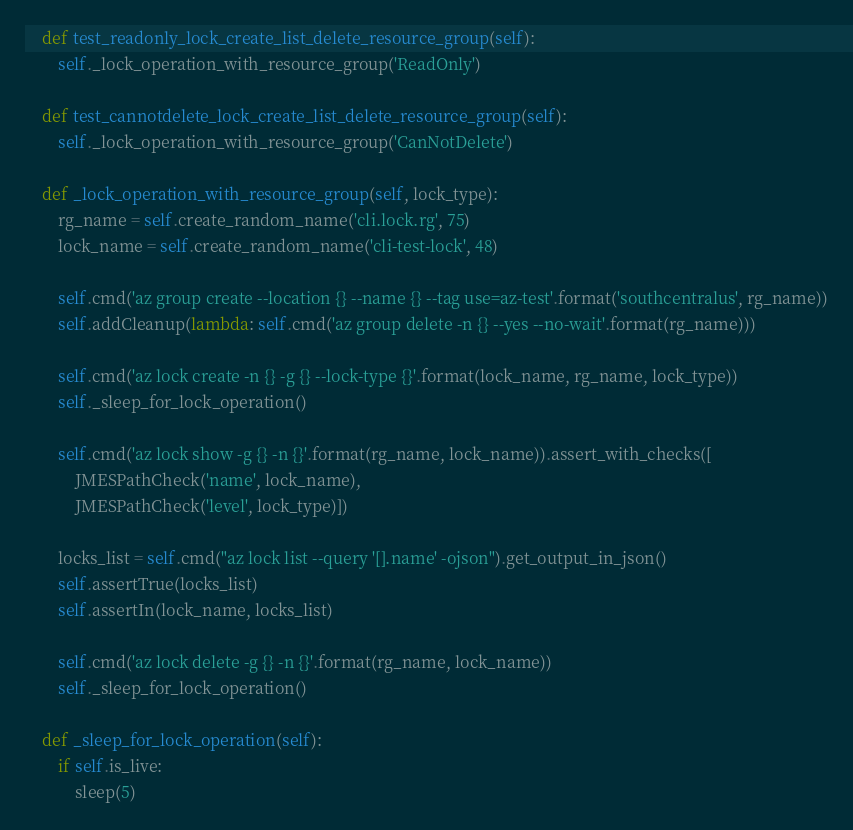Convert code to text. <code><loc_0><loc_0><loc_500><loc_500><_Python_>
    def test_readonly_lock_create_list_delete_resource_group(self):
        self._lock_operation_with_resource_group('ReadOnly')

    def test_cannotdelete_lock_create_list_delete_resource_group(self):
        self._lock_operation_with_resource_group('CanNotDelete')

    def _lock_operation_with_resource_group(self, lock_type):
        rg_name = self.create_random_name('cli.lock.rg', 75)
        lock_name = self.create_random_name('cli-test-lock', 48)

        self.cmd('az group create --location {} --name {} --tag use=az-test'.format('southcentralus', rg_name))
        self.addCleanup(lambda: self.cmd('az group delete -n {} --yes --no-wait'.format(rg_name)))

        self.cmd('az lock create -n {} -g {} --lock-type {}'.format(lock_name, rg_name, lock_type))
        self._sleep_for_lock_operation()

        self.cmd('az lock show -g {} -n {}'.format(rg_name, lock_name)).assert_with_checks([
            JMESPathCheck('name', lock_name),
            JMESPathCheck('level', lock_type)])

        locks_list = self.cmd("az lock list --query '[].name' -ojson").get_output_in_json()
        self.assertTrue(locks_list)
        self.assertIn(lock_name, locks_list)

        self.cmd('az lock delete -g {} -n {}'.format(rg_name, lock_name))
        self._sleep_for_lock_operation()

    def _sleep_for_lock_operation(self):
        if self.is_live:
            sleep(5)
</code> 